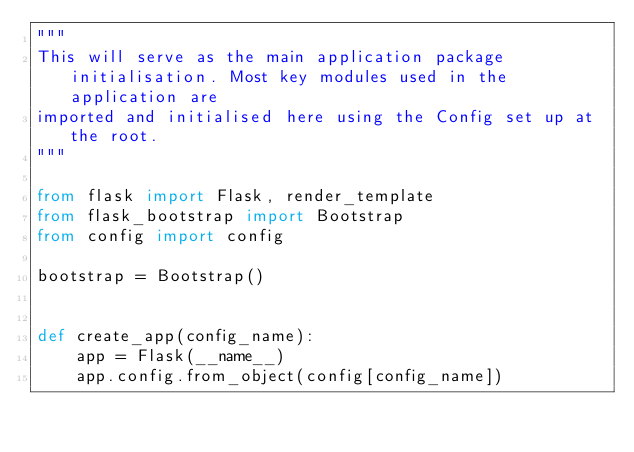<code> <loc_0><loc_0><loc_500><loc_500><_Python_>"""
This will serve as the main application package initialisation. Most key modules used in the application are
imported and initialised here using the Config set up at the root.
"""

from flask import Flask, render_template
from flask_bootstrap import Bootstrap
from config import config

bootstrap = Bootstrap()


def create_app(config_name):
    app = Flask(__name__)
    app.config.from_object(config[config_name])</code> 